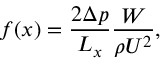Convert formula to latex. <formula><loc_0><loc_0><loc_500><loc_500>{ f ( x ) = \frac { 2 \Delta p } { L _ { x } } \frac { W } { \rho U ^ { 2 } } , }</formula> 